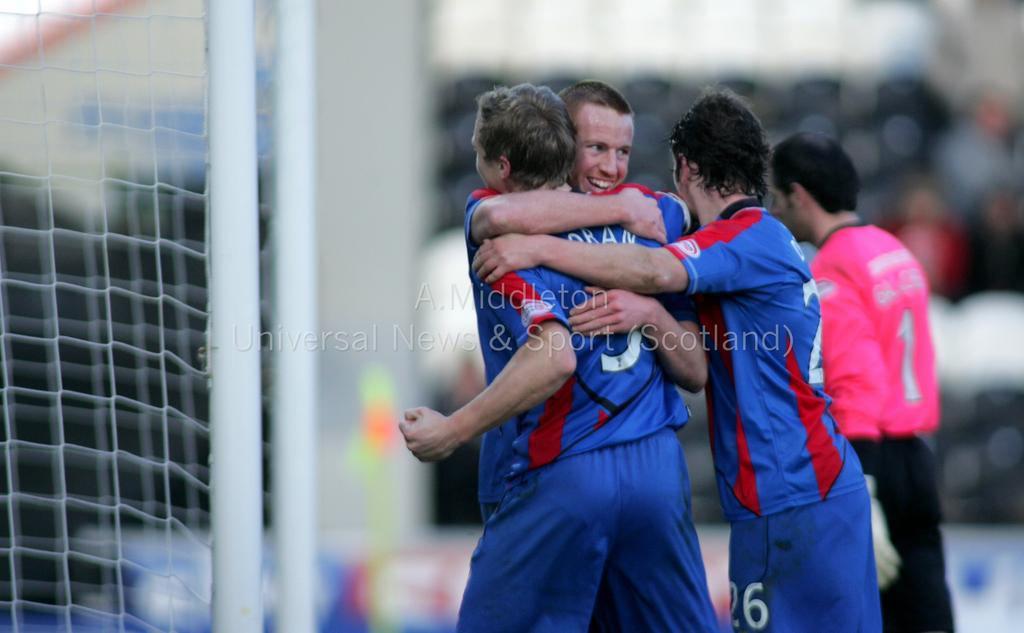Provide a one-sentence caption for the provided image. Players in blue jerseys, one wearing a 26, hug the player 5, Oran. 